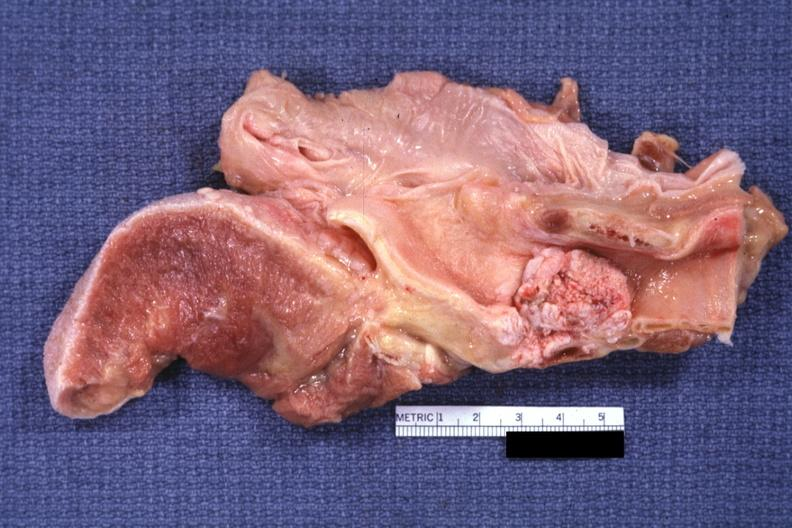s larynx present?
Answer the question using a single word or phrase. Yes 